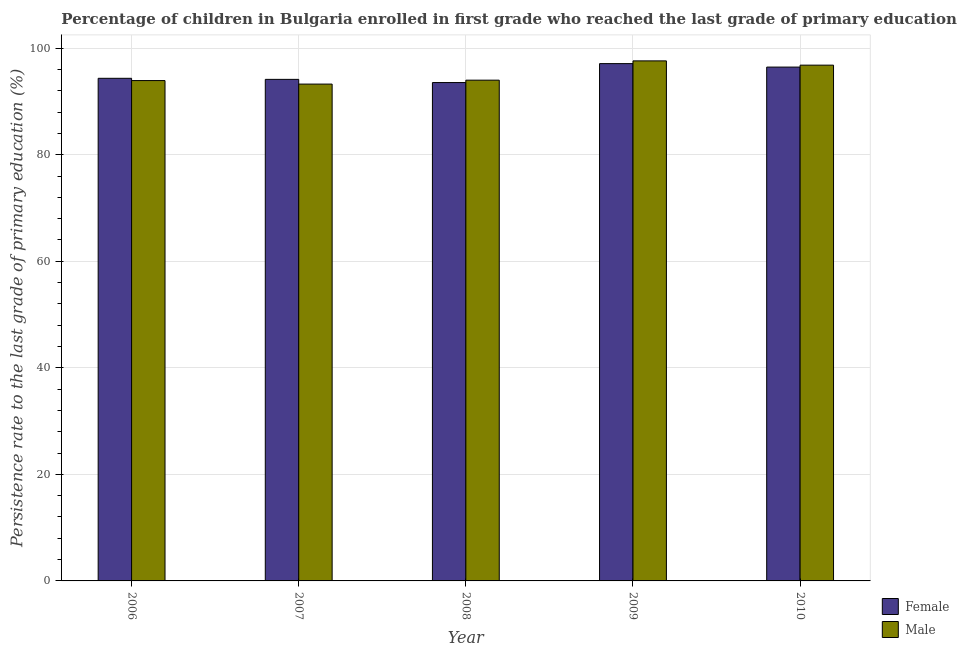How many different coloured bars are there?
Make the answer very short. 2. Are the number of bars per tick equal to the number of legend labels?
Offer a very short reply. Yes. In how many cases, is the number of bars for a given year not equal to the number of legend labels?
Keep it short and to the point. 0. What is the persistence rate of female students in 2006?
Give a very brief answer. 94.35. Across all years, what is the maximum persistence rate of male students?
Provide a succinct answer. 97.62. Across all years, what is the minimum persistence rate of female students?
Make the answer very short. 93.55. In which year was the persistence rate of male students minimum?
Make the answer very short. 2007. What is the total persistence rate of male students in the graph?
Make the answer very short. 475.61. What is the difference between the persistence rate of male students in 2006 and that in 2008?
Your answer should be compact. -0.08. What is the difference between the persistence rate of male students in 2008 and the persistence rate of female students in 2010?
Keep it short and to the point. -2.82. What is the average persistence rate of female students per year?
Provide a succinct answer. 95.12. What is the ratio of the persistence rate of female students in 2008 to that in 2010?
Keep it short and to the point. 0.97. Is the persistence rate of female students in 2006 less than that in 2007?
Provide a short and direct response. No. Is the difference between the persistence rate of male students in 2008 and 2009 greater than the difference between the persistence rate of female students in 2008 and 2009?
Offer a very short reply. No. What is the difference between the highest and the second highest persistence rate of male students?
Your answer should be compact. 0.8. What is the difference between the highest and the lowest persistence rate of male students?
Offer a very short reply. 4.36. In how many years, is the persistence rate of female students greater than the average persistence rate of female students taken over all years?
Offer a very short reply. 2. Is the sum of the persistence rate of male students in 2006 and 2008 greater than the maximum persistence rate of female students across all years?
Make the answer very short. Yes. How many bars are there?
Ensure brevity in your answer.  10. What is the difference between two consecutive major ticks on the Y-axis?
Give a very brief answer. 20. Does the graph contain any zero values?
Provide a succinct answer. No. Where does the legend appear in the graph?
Ensure brevity in your answer.  Bottom right. How are the legend labels stacked?
Offer a very short reply. Vertical. What is the title of the graph?
Provide a short and direct response. Percentage of children in Bulgaria enrolled in first grade who reached the last grade of primary education. What is the label or title of the Y-axis?
Ensure brevity in your answer.  Persistence rate to the last grade of primary education (%). What is the Persistence rate to the last grade of primary education (%) of Female in 2006?
Offer a terse response. 94.35. What is the Persistence rate to the last grade of primary education (%) of Male in 2006?
Offer a very short reply. 93.92. What is the Persistence rate to the last grade of primary education (%) in Female in 2007?
Keep it short and to the point. 94.15. What is the Persistence rate to the last grade of primary education (%) of Male in 2007?
Offer a very short reply. 93.26. What is the Persistence rate to the last grade of primary education (%) of Female in 2008?
Keep it short and to the point. 93.55. What is the Persistence rate to the last grade of primary education (%) of Male in 2008?
Ensure brevity in your answer.  94. What is the Persistence rate to the last grade of primary education (%) in Female in 2009?
Provide a succinct answer. 97.1. What is the Persistence rate to the last grade of primary education (%) in Male in 2009?
Keep it short and to the point. 97.62. What is the Persistence rate to the last grade of primary education (%) of Female in 2010?
Keep it short and to the point. 96.45. What is the Persistence rate to the last grade of primary education (%) in Male in 2010?
Provide a short and direct response. 96.81. Across all years, what is the maximum Persistence rate to the last grade of primary education (%) of Female?
Offer a very short reply. 97.1. Across all years, what is the maximum Persistence rate to the last grade of primary education (%) in Male?
Ensure brevity in your answer.  97.62. Across all years, what is the minimum Persistence rate to the last grade of primary education (%) in Female?
Your answer should be very brief. 93.55. Across all years, what is the minimum Persistence rate to the last grade of primary education (%) of Male?
Your response must be concise. 93.26. What is the total Persistence rate to the last grade of primary education (%) in Female in the graph?
Your answer should be very brief. 475.59. What is the total Persistence rate to the last grade of primary education (%) in Male in the graph?
Your response must be concise. 475.61. What is the difference between the Persistence rate to the last grade of primary education (%) of Female in 2006 and that in 2007?
Your answer should be compact. 0.2. What is the difference between the Persistence rate to the last grade of primary education (%) in Male in 2006 and that in 2007?
Keep it short and to the point. 0.66. What is the difference between the Persistence rate to the last grade of primary education (%) of Female in 2006 and that in 2008?
Offer a terse response. 0.8. What is the difference between the Persistence rate to the last grade of primary education (%) in Male in 2006 and that in 2008?
Offer a terse response. -0.08. What is the difference between the Persistence rate to the last grade of primary education (%) in Female in 2006 and that in 2009?
Your answer should be very brief. -2.76. What is the difference between the Persistence rate to the last grade of primary education (%) of Male in 2006 and that in 2009?
Offer a terse response. -3.7. What is the difference between the Persistence rate to the last grade of primary education (%) of Female in 2006 and that in 2010?
Provide a short and direct response. -2.1. What is the difference between the Persistence rate to the last grade of primary education (%) of Male in 2006 and that in 2010?
Provide a short and direct response. -2.89. What is the difference between the Persistence rate to the last grade of primary education (%) in Female in 2007 and that in 2008?
Provide a short and direct response. 0.6. What is the difference between the Persistence rate to the last grade of primary education (%) of Male in 2007 and that in 2008?
Your answer should be very brief. -0.74. What is the difference between the Persistence rate to the last grade of primary education (%) of Female in 2007 and that in 2009?
Ensure brevity in your answer.  -2.96. What is the difference between the Persistence rate to the last grade of primary education (%) in Male in 2007 and that in 2009?
Your answer should be very brief. -4.36. What is the difference between the Persistence rate to the last grade of primary education (%) of Female in 2007 and that in 2010?
Your response must be concise. -2.31. What is the difference between the Persistence rate to the last grade of primary education (%) of Male in 2007 and that in 2010?
Make the answer very short. -3.55. What is the difference between the Persistence rate to the last grade of primary education (%) in Female in 2008 and that in 2009?
Your answer should be compact. -3.56. What is the difference between the Persistence rate to the last grade of primary education (%) of Male in 2008 and that in 2009?
Offer a terse response. -3.62. What is the difference between the Persistence rate to the last grade of primary education (%) in Female in 2008 and that in 2010?
Ensure brevity in your answer.  -2.9. What is the difference between the Persistence rate to the last grade of primary education (%) of Male in 2008 and that in 2010?
Keep it short and to the point. -2.82. What is the difference between the Persistence rate to the last grade of primary education (%) in Female in 2009 and that in 2010?
Give a very brief answer. 0.65. What is the difference between the Persistence rate to the last grade of primary education (%) of Male in 2009 and that in 2010?
Give a very brief answer. 0.8. What is the difference between the Persistence rate to the last grade of primary education (%) in Female in 2006 and the Persistence rate to the last grade of primary education (%) in Male in 2007?
Provide a succinct answer. 1.09. What is the difference between the Persistence rate to the last grade of primary education (%) of Female in 2006 and the Persistence rate to the last grade of primary education (%) of Male in 2008?
Your answer should be very brief. 0.35. What is the difference between the Persistence rate to the last grade of primary education (%) in Female in 2006 and the Persistence rate to the last grade of primary education (%) in Male in 2009?
Your response must be concise. -3.27. What is the difference between the Persistence rate to the last grade of primary education (%) in Female in 2006 and the Persistence rate to the last grade of primary education (%) in Male in 2010?
Make the answer very short. -2.47. What is the difference between the Persistence rate to the last grade of primary education (%) in Female in 2007 and the Persistence rate to the last grade of primary education (%) in Male in 2008?
Give a very brief answer. 0.15. What is the difference between the Persistence rate to the last grade of primary education (%) in Female in 2007 and the Persistence rate to the last grade of primary education (%) in Male in 2009?
Offer a very short reply. -3.47. What is the difference between the Persistence rate to the last grade of primary education (%) of Female in 2007 and the Persistence rate to the last grade of primary education (%) of Male in 2010?
Offer a very short reply. -2.67. What is the difference between the Persistence rate to the last grade of primary education (%) in Female in 2008 and the Persistence rate to the last grade of primary education (%) in Male in 2009?
Provide a succinct answer. -4.07. What is the difference between the Persistence rate to the last grade of primary education (%) in Female in 2008 and the Persistence rate to the last grade of primary education (%) in Male in 2010?
Provide a short and direct response. -3.27. What is the difference between the Persistence rate to the last grade of primary education (%) of Female in 2009 and the Persistence rate to the last grade of primary education (%) of Male in 2010?
Provide a succinct answer. 0.29. What is the average Persistence rate to the last grade of primary education (%) of Female per year?
Your response must be concise. 95.12. What is the average Persistence rate to the last grade of primary education (%) of Male per year?
Provide a short and direct response. 95.12. In the year 2006, what is the difference between the Persistence rate to the last grade of primary education (%) in Female and Persistence rate to the last grade of primary education (%) in Male?
Your response must be concise. 0.42. In the year 2007, what is the difference between the Persistence rate to the last grade of primary education (%) of Female and Persistence rate to the last grade of primary education (%) of Male?
Ensure brevity in your answer.  0.89. In the year 2008, what is the difference between the Persistence rate to the last grade of primary education (%) of Female and Persistence rate to the last grade of primary education (%) of Male?
Your answer should be very brief. -0.45. In the year 2009, what is the difference between the Persistence rate to the last grade of primary education (%) in Female and Persistence rate to the last grade of primary education (%) in Male?
Offer a very short reply. -0.51. In the year 2010, what is the difference between the Persistence rate to the last grade of primary education (%) of Female and Persistence rate to the last grade of primary education (%) of Male?
Provide a succinct answer. -0.36. What is the ratio of the Persistence rate to the last grade of primary education (%) in Female in 2006 to that in 2007?
Your answer should be very brief. 1. What is the ratio of the Persistence rate to the last grade of primary education (%) of Male in 2006 to that in 2007?
Your answer should be compact. 1.01. What is the ratio of the Persistence rate to the last grade of primary education (%) in Female in 2006 to that in 2008?
Keep it short and to the point. 1.01. What is the ratio of the Persistence rate to the last grade of primary education (%) in Female in 2006 to that in 2009?
Ensure brevity in your answer.  0.97. What is the ratio of the Persistence rate to the last grade of primary education (%) of Male in 2006 to that in 2009?
Make the answer very short. 0.96. What is the ratio of the Persistence rate to the last grade of primary education (%) in Female in 2006 to that in 2010?
Provide a short and direct response. 0.98. What is the ratio of the Persistence rate to the last grade of primary education (%) of Male in 2006 to that in 2010?
Keep it short and to the point. 0.97. What is the ratio of the Persistence rate to the last grade of primary education (%) of Female in 2007 to that in 2008?
Give a very brief answer. 1.01. What is the ratio of the Persistence rate to the last grade of primary education (%) in Female in 2007 to that in 2009?
Your response must be concise. 0.97. What is the ratio of the Persistence rate to the last grade of primary education (%) of Male in 2007 to that in 2009?
Your answer should be compact. 0.96. What is the ratio of the Persistence rate to the last grade of primary education (%) of Female in 2007 to that in 2010?
Offer a terse response. 0.98. What is the ratio of the Persistence rate to the last grade of primary education (%) of Male in 2007 to that in 2010?
Make the answer very short. 0.96. What is the ratio of the Persistence rate to the last grade of primary education (%) in Female in 2008 to that in 2009?
Your response must be concise. 0.96. What is the ratio of the Persistence rate to the last grade of primary education (%) in Male in 2008 to that in 2009?
Provide a short and direct response. 0.96. What is the ratio of the Persistence rate to the last grade of primary education (%) of Female in 2008 to that in 2010?
Ensure brevity in your answer.  0.97. What is the ratio of the Persistence rate to the last grade of primary education (%) in Male in 2008 to that in 2010?
Ensure brevity in your answer.  0.97. What is the ratio of the Persistence rate to the last grade of primary education (%) of Female in 2009 to that in 2010?
Make the answer very short. 1.01. What is the ratio of the Persistence rate to the last grade of primary education (%) of Male in 2009 to that in 2010?
Provide a succinct answer. 1.01. What is the difference between the highest and the second highest Persistence rate to the last grade of primary education (%) in Female?
Keep it short and to the point. 0.65. What is the difference between the highest and the second highest Persistence rate to the last grade of primary education (%) of Male?
Your answer should be very brief. 0.8. What is the difference between the highest and the lowest Persistence rate to the last grade of primary education (%) of Female?
Give a very brief answer. 3.56. What is the difference between the highest and the lowest Persistence rate to the last grade of primary education (%) in Male?
Give a very brief answer. 4.36. 